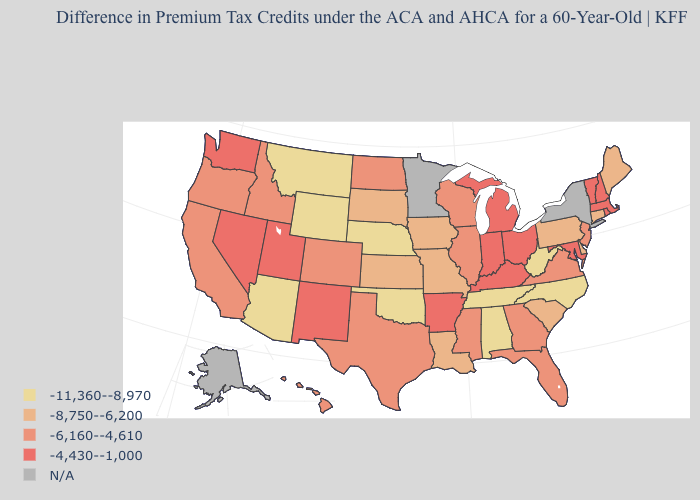What is the highest value in the West ?
Answer briefly. -4,430--1,000. What is the value of Nebraska?
Concise answer only. -11,360--8,970. Name the states that have a value in the range -11,360--8,970?
Quick response, please. Alabama, Arizona, Montana, Nebraska, North Carolina, Oklahoma, Tennessee, West Virginia, Wyoming. What is the lowest value in the USA?
Quick response, please. -11,360--8,970. What is the value of Louisiana?
Write a very short answer. -8,750--6,200. What is the lowest value in states that border Delaware?
Give a very brief answer. -8,750--6,200. Name the states that have a value in the range -8,750--6,200?
Write a very short answer. Connecticut, Delaware, Iowa, Kansas, Louisiana, Maine, Missouri, Pennsylvania, South Carolina, South Dakota. What is the lowest value in states that border North Dakota?
Be succinct. -11,360--8,970. How many symbols are there in the legend?
Answer briefly. 5. Is the legend a continuous bar?
Concise answer only. No. Does the map have missing data?
Quick response, please. Yes. Which states have the lowest value in the USA?
Give a very brief answer. Alabama, Arizona, Montana, Nebraska, North Carolina, Oklahoma, Tennessee, West Virginia, Wyoming. Among the states that border New Hampshire , which have the lowest value?
Be succinct. Maine. Among the states that border California , which have the highest value?
Short answer required. Nevada. Name the states that have a value in the range -6,160--4,610?
Short answer required. California, Colorado, Florida, Georgia, Hawaii, Idaho, Illinois, Mississippi, New Jersey, North Dakota, Oregon, Texas, Virginia, Wisconsin. 